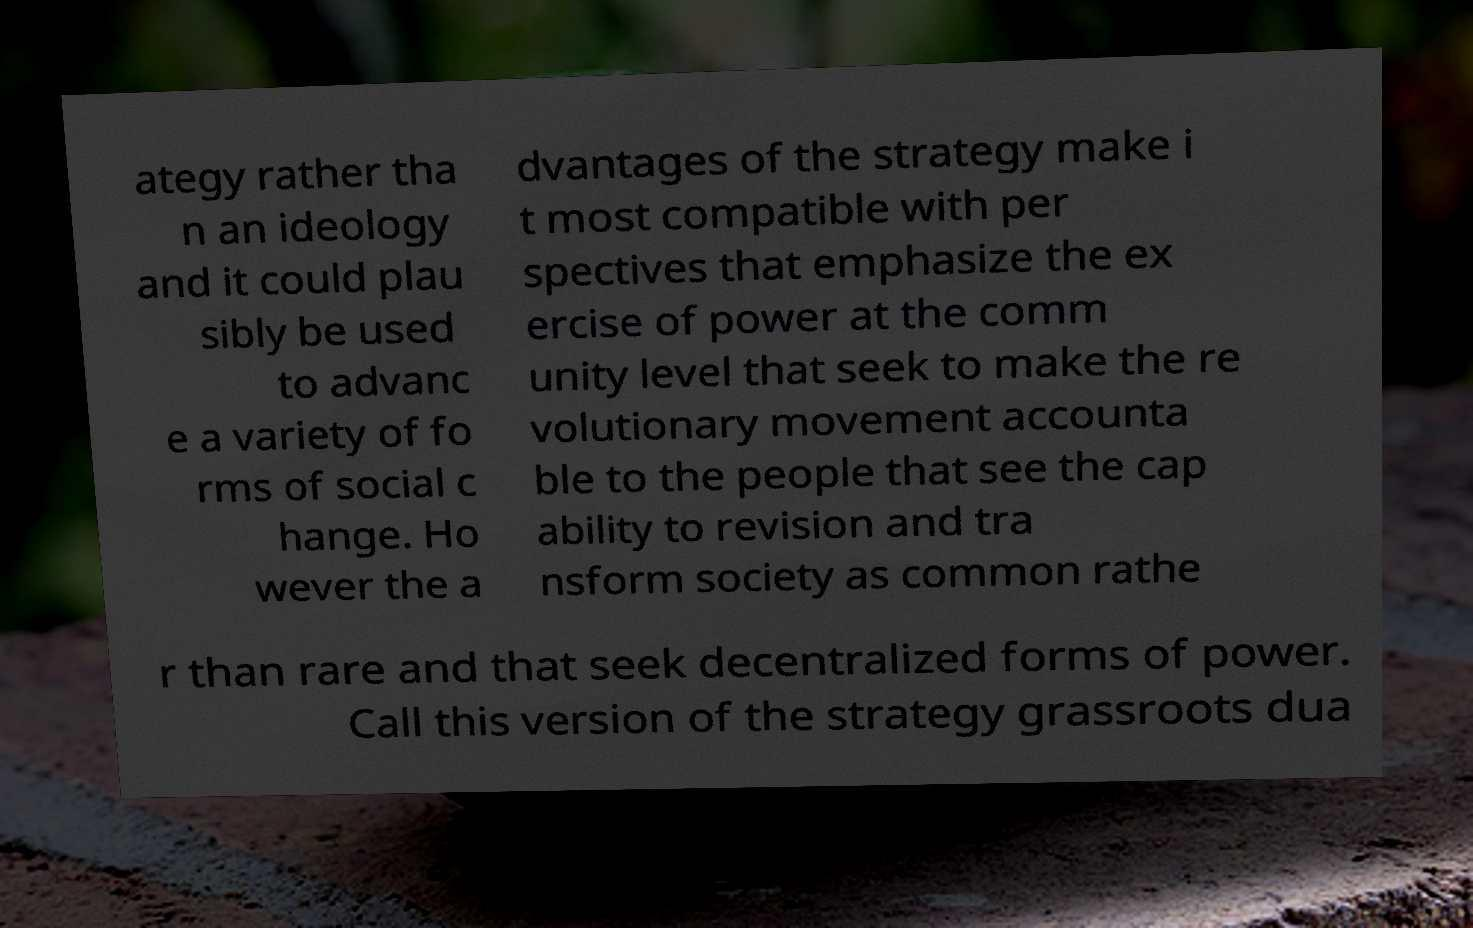Can you read and provide the text displayed in the image?This photo seems to have some interesting text. Can you extract and type it out for me? ategy rather tha n an ideology and it could plau sibly be used to advanc e a variety of fo rms of social c hange. Ho wever the a dvantages of the strategy make i t most compatible with per spectives that emphasize the ex ercise of power at the comm unity level that seek to make the re volutionary movement accounta ble to the people that see the cap ability to revision and tra nsform society as common rathe r than rare and that seek decentralized forms of power. Call this version of the strategy grassroots dua 